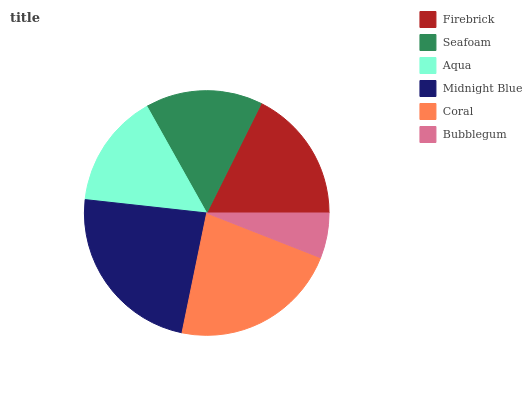Is Bubblegum the minimum?
Answer yes or no. Yes. Is Midnight Blue the maximum?
Answer yes or no. Yes. Is Seafoam the minimum?
Answer yes or no. No. Is Seafoam the maximum?
Answer yes or no. No. Is Firebrick greater than Seafoam?
Answer yes or no. Yes. Is Seafoam less than Firebrick?
Answer yes or no. Yes. Is Seafoam greater than Firebrick?
Answer yes or no. No. Is Firebrick less than Seafoam?
Answer yes or no. No. Is Firebrick the high median?
Answer yes or no. Yes. Is Seafoam the low median?
Answer yes or no. Yes. Is Coral the high median?
Answer yes or no. No. Is Bubblegum the low median?
Answer yes or no. No. 